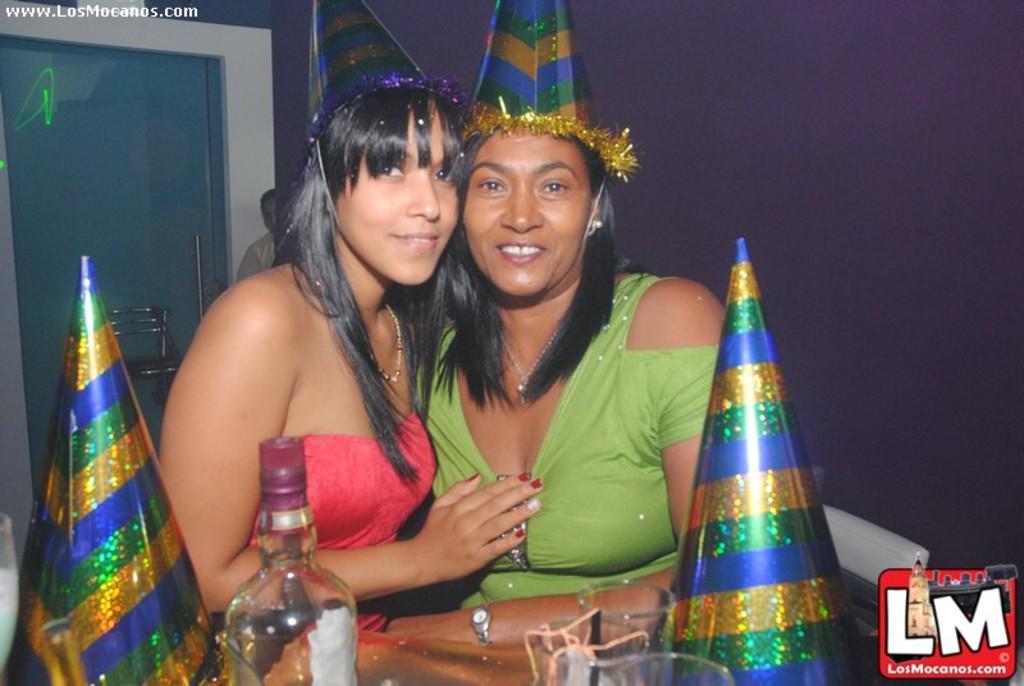In one or two sentences, can you explain what this image depicts? In this picture we can see two women holding a smile on their faces and they both wore attractive caps. Here we can see bottle, caps and glasses in front of the picture. On the background we can see a wall. 